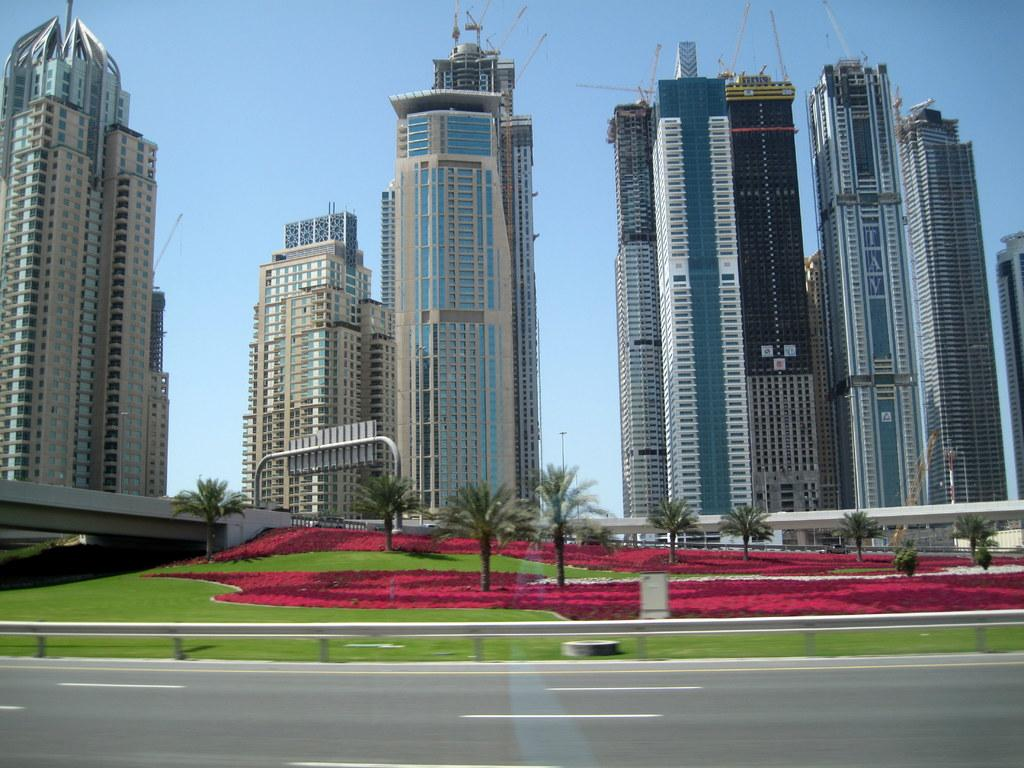What type of structures can be seen in the image? There are buildings in the image. What is the ground cover at the bottom of the image? Green grass and small plants in red color are visible at the bottom of the image. Is there any indication of a path or route in the image? Yes, there is a road in the image. What can be seen in the sky in the image? The sky is visible at the top of the image. What is the price of the goat in the image? There is no goat present in the image, so it is not possible to determine its price. 